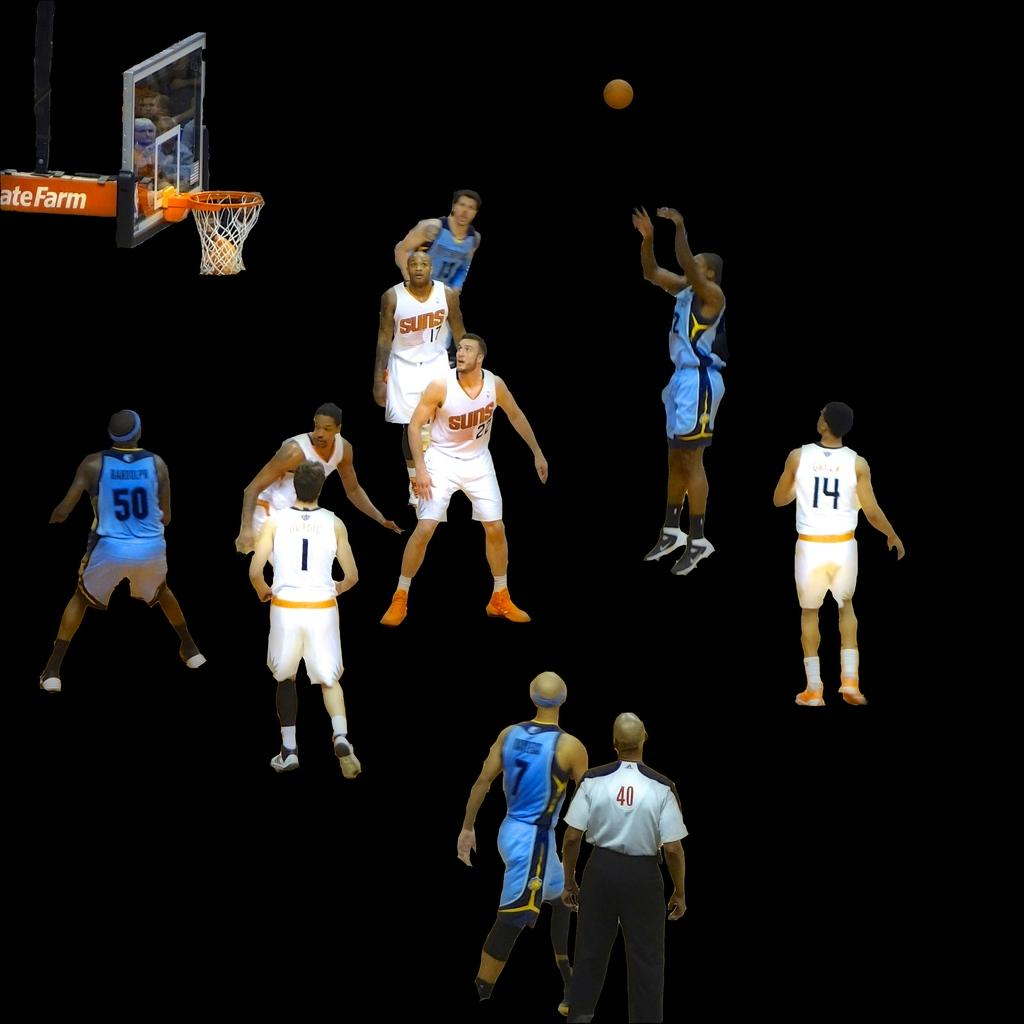<image>
Relay a brief, clear account of the picture shown. Group of basketball players including one wearing number 14 watching someone shoot. 